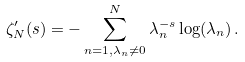<formula> <loc_0><loc_0><loc_500><loc_500>\zeta ^ { \prime } _ { N } ( s ) = - \sum _ { n = 1 , \lambda _ { n } \neq 0 } ^ { N } \lambda _ { n } ^ { - s } \log ( \lambda _ { n } ) \, .</formula> 